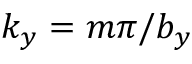Convert formula to latex. <formula><loc_0><loc_0><loc_500><loc_500>k _ { y } = m \pi / b _ { y }</formula> 